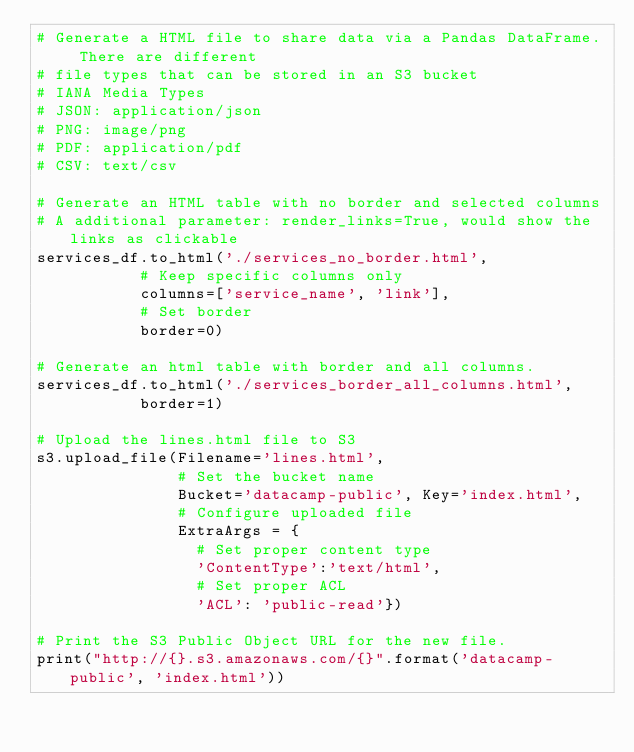Convert code to text. <code><loc_0><loc_0><loc_500><loc_500><_Python_># Generate a HTML file to share data via a Pandas DataFrame. There are different
# file types that can be stored in an S3 bucket
# IANA Media Types
# JSON: application/json
# PNG: image/png
# PDF: application/pdf
# CSV: text/csv

# Generate an HTML table with no border and selected columns
# A additional parameter: render_links=True, would show the links as clickable
services_df.to_html('./services_no_border.html',
           # Keep specific columns only
           columns=['service_name', 'link'],
           # Set border
           border=0)

# Generate an html table with border and all columns.
services_df.to_html('./services_border_all_columns.html', 
           border=1)

# Upload the lines.html file to S3
s3.upload_file(Filename='lines.html', 
               # Set the bucket name
               Bucket='datacamp-public', Key='index.html',
               # Configure uploaded file
               ExtraArgs = {
                 # Set proper content type
                 'ContentType':'text/html',
                 # Set proper ACL
                 'ACL': 'public-read'})

# Print the S3 Public Object URL for the new file.
print("http://{}.s3.amazonaws.com/{}".format('datacamp-public', 'index.html'))
</code> 